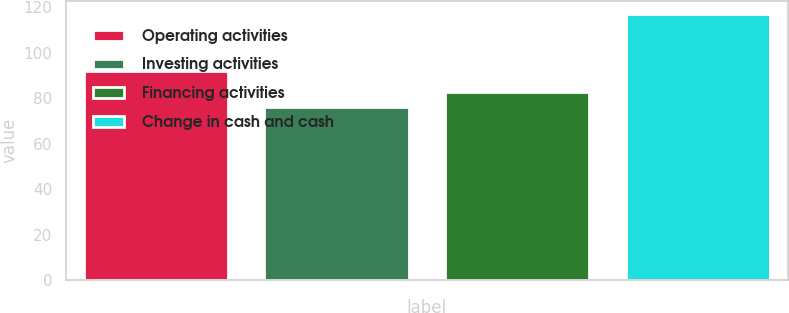Convert chart. <chart><loc_0><loc_0><loc_500><loc_500><bar_chart><fcel>Operating activities<fcel>Investing activities<fcel>Financing activities<fcel>Change in cash and cash<nl><fcel>92<fcel>76<fcel>83<fcel>117<nl></chart> 